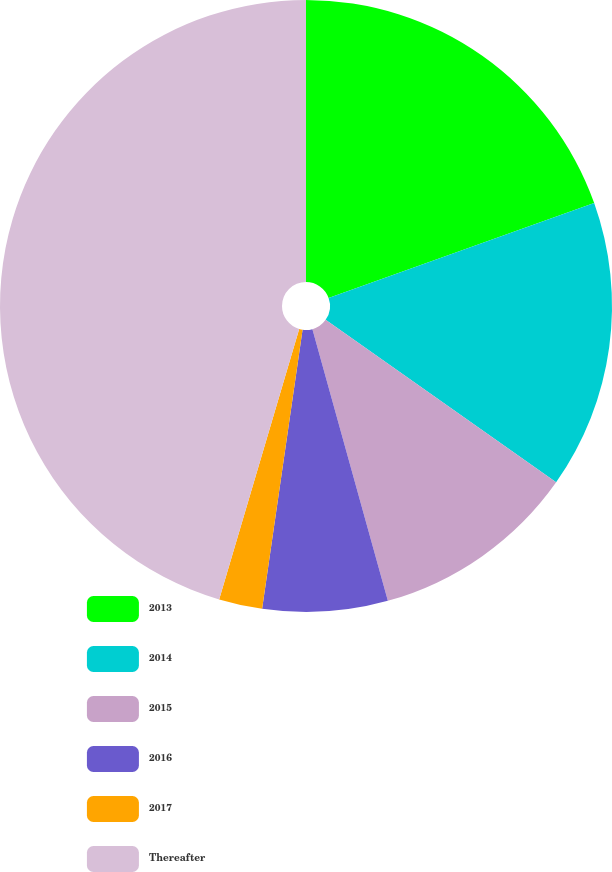<chart> <loc_0><loc_0><loc_500><loc_500><pie_chart><fcel>2013<fcel>2014<fcel>2015<fcel>2016<fcel>2017<fcel>Thereafter<nl><fcel>19.54%<fcel>15.23%<fcel>10.92%<fcel>6.6%<fcel>2.29%<fcel>45.42%<nl></chart> 